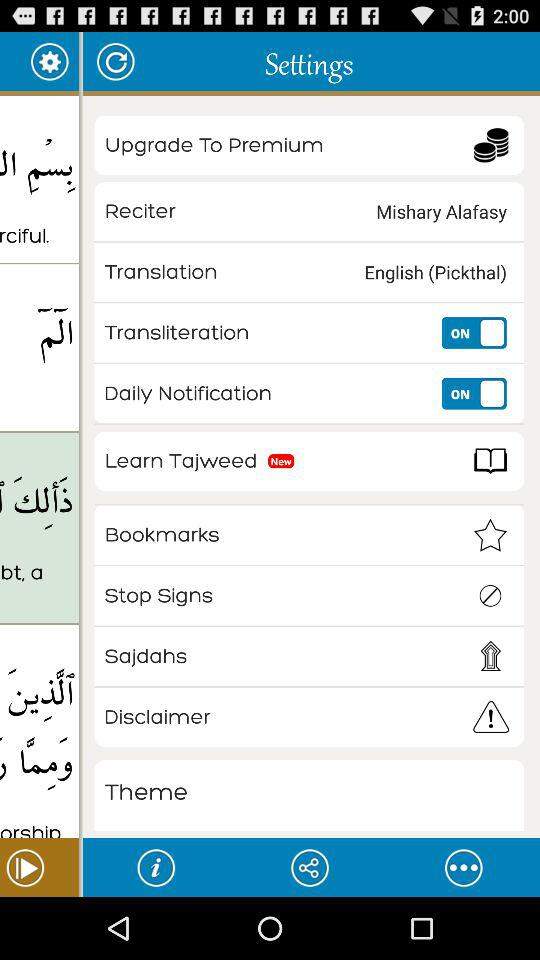What is selected in "Reciter"? The selection in "Reciter" is "Mishary Alafasy". 